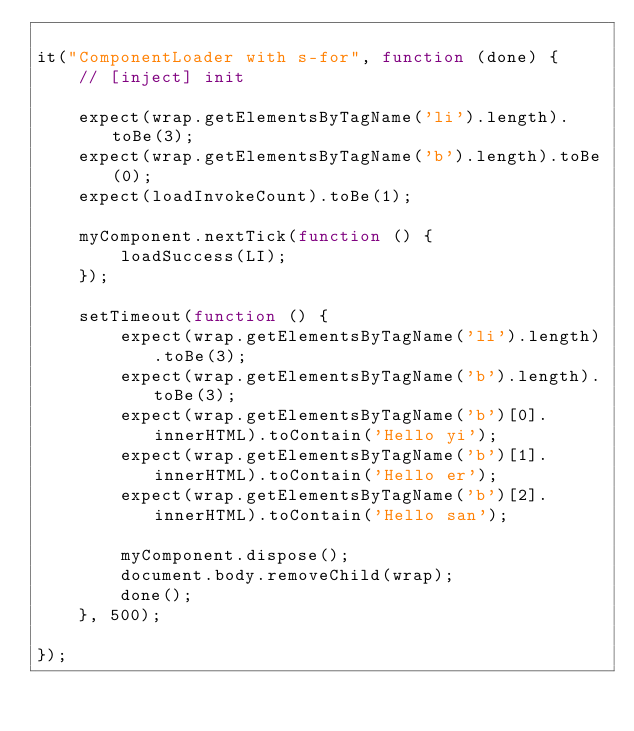<code> <loc_0><loc_0><loc_500><loc_500><_JavaScript_>
it("ComponentLoader with s-for", function (done) {
    // [inject] init

    expect(wrap.getElementsByTagName('li').length).toBe(3);
    expect(wrap.getElementsByTagName('b').length).toBe(0);
    expect(loadInvokeCount).toBe(1);

    myComponent.nextTick(function () {
        loadSuccess(LI);
    });

    setTimeout(function () {
        expect(wrap.getElementsByTagName('li').length).toBe(3);
        expect(wrap.getElementsByTagName('b').length).toBe(3);
        expect(wrap.getElementsByTagName('b')[0].innerHTML).toContain('Hello yi');
        expect(wrap.getElementsByTagName('b')[1].innerHTML).toContain('Hello er');
        expect(wrap.getElementsByTagName('b')[2].innerHTML).toContain('Hello san');

        myComponent.dispose();
        document.body.removeChild(wrap);
        done();
    }, 500);

});
</code> 